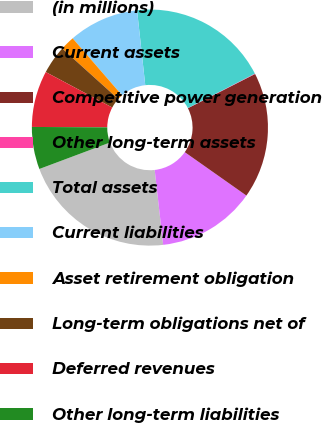Convert chart to OTSL. <chart><loc_0><loc_0><loc_500><loc_500><pie_chart><fcel>(in millions)<fcel>Current assets<fcel>Competitive power generation<fcel>Other long-term assets<fcel>Total assets<fcel>Current liabilities<fcel>Asset retirement obligation<fcel>Long-term obligations net of<fcel>Deferred revenues<fcel>Other long-term liabilities<nl><fcel>21.09%<fcel>13.44%<fcel>17.27%<fcel>0.06%<fcel>19.18%<fcel>9.62%<fcel>1.97%<fcel>3.88%<fcel>7.71%<fcel>5.79%<nl></chart> 